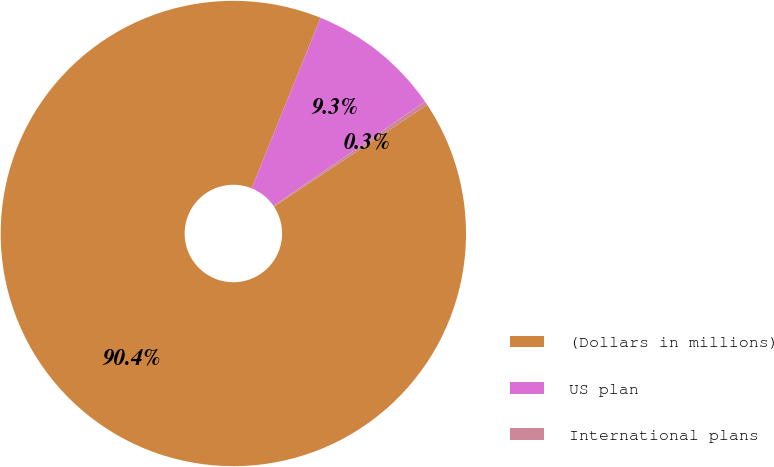Convert chart. <chart><loc_0><loc_0><loc_500><loc_500><pie_chart><fcel>(Dollars in millions)<fcel>US plan<fcel>International plans<nl><fcel>90.44%<fcel>9.29%<fcel>0.27%<nl></chart> 